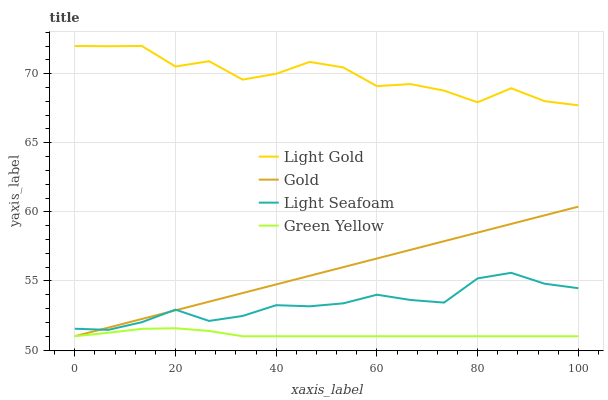Does Green Yellow have the minimum area under the curve?
Answer yes or no. Yes. Does Light Gold have the maximum area under the curve?
Answer yes or no. Yes. Does Light Seafoam have the minimum area under the curve?
Answer yes or no. No. Does Light Seafoam have the maximum area under the curve?
Answer yes or no. No. Is Gold the smoothest?
Answer yes or no. Yes. Is Light Gold the roughest?
Answer yes or no. Yes. Is Light Seafoam the smoothest?
Answer yes or no. No. Is Light Seafoam the roughest?
Answer yes or no. No. Does Green Yellow have the lowest value?
Answer yes or no. Yes. Does Light Seafoam have the lowest value?
Answer yes or no. No. Does Light Gold have the highest value?
Answer yes or no. Yes. Does Light Seafoam have the highest value?
Answer yes or no. No. Is Green Yellow less than Light Seafoam?
Answer yes or no. Yes. Is Light Seafoam greater than Green Yellow?
Answer yes or no. Yes. Does Green Yellow intersect Gold?
Answer yes or no. Yes. Is Green Yellow less than Gold?
Answer yes or no. No. Is Green Yellow greater than Gold?
Answer yes or no. No. Does Green Yellow intersect Light Seafoam?
Answer yes or no. No. 